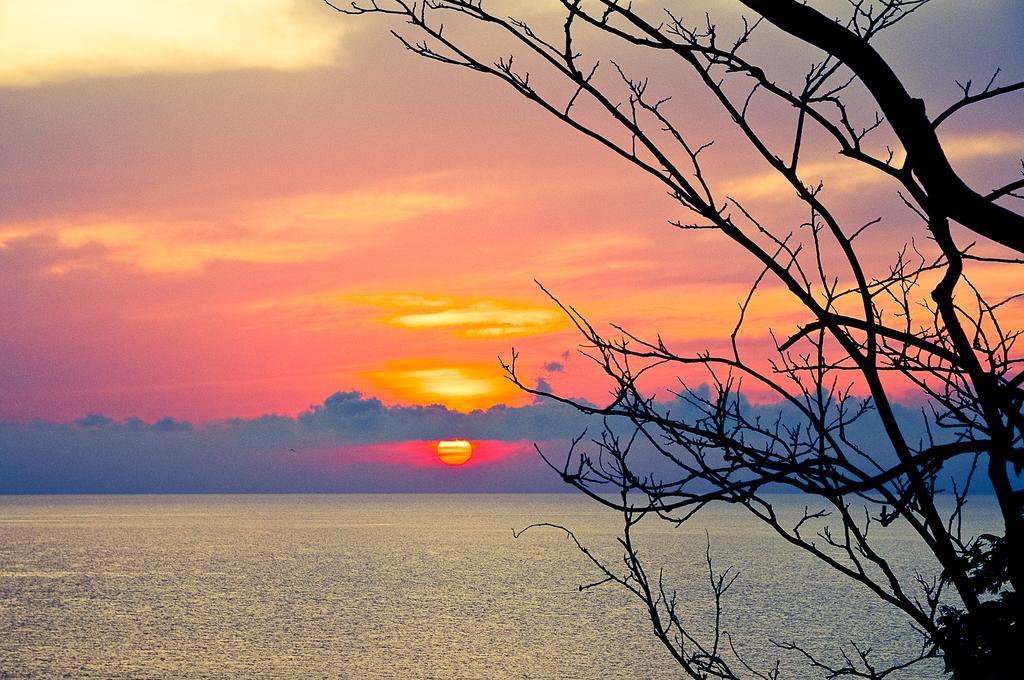How would you summarize this image in a sentence or two? In the foreground of this image, on the right, there is a tree without leaves. In the background, there is water, sky and the sun. 